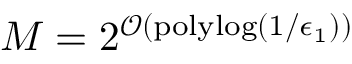<formula> <loc_0><loc_0><loc_500><loc_500>M = 2 ^ { \mathcal { O } ( p o l y \log ( 1 / \epsilon _ { 1 } ) ) }</formula> 